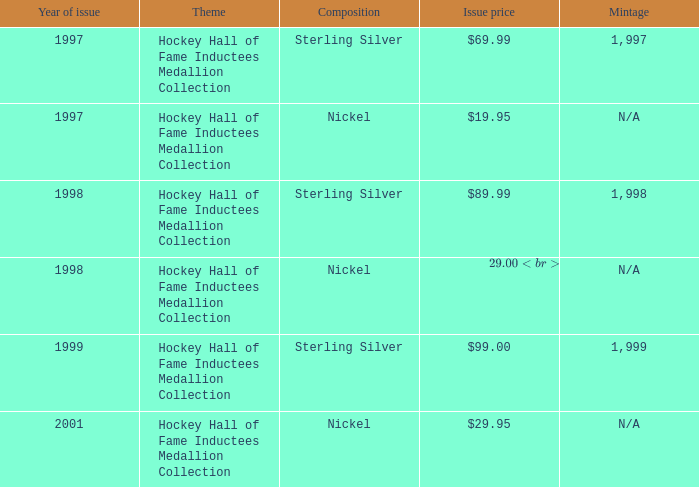For how many years was the subject rate $1 1.0. 